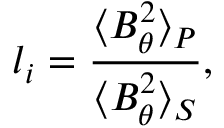Convert formula to latex. <formula><loc_0><loc_0><loc_500><loc_500>l _ { i } = \frac { \langle B _ { \theta } ^ { 2 } \rangle _ { P } } { \langle B _ { \theta } ^ { 2 } \rangle _ { S } } ,</formula> 